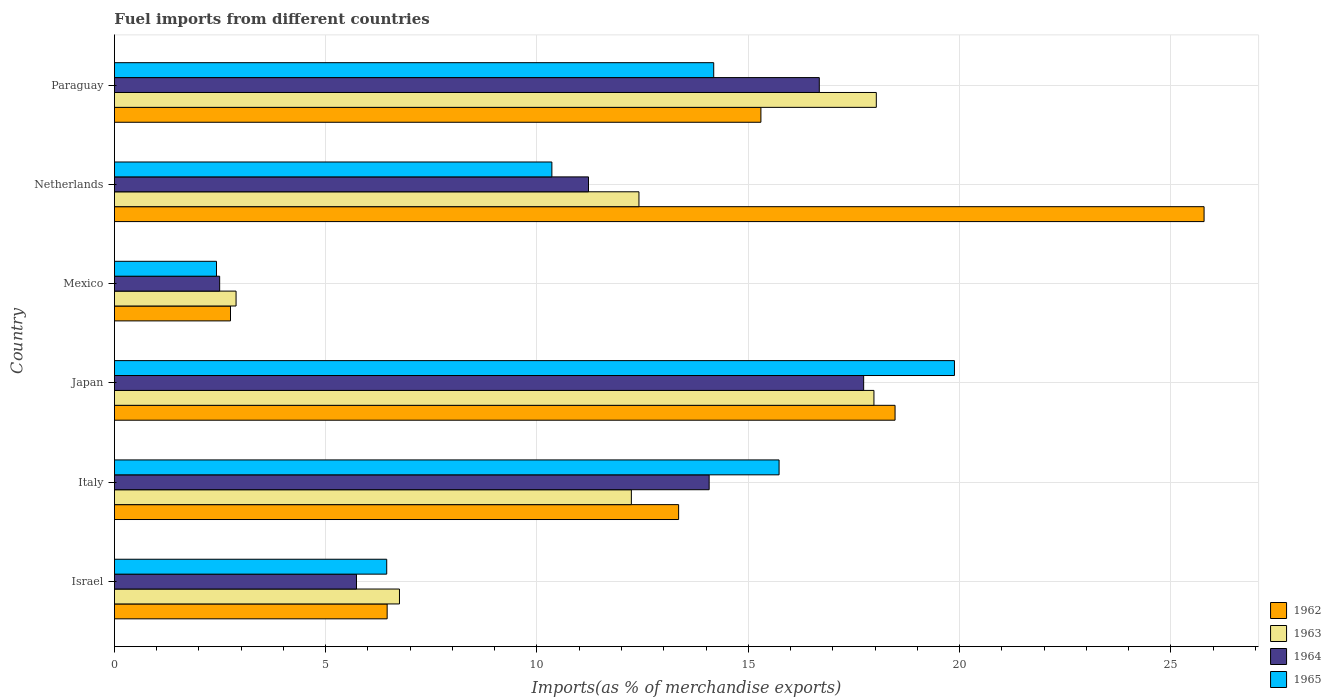Are the number of bars per tick equal to the number of legend labels?
Provide a short and direct response. Yes. How many bars are there on the 3rd tick from the top?
Ensure brevity in your answer.  4. How many bars are there on the 5th tick from the bottom?
Your response must be concise. 4. What is the label of the 5th group of bars from the top?
Keep it short and to the point. Italy. What is the percentage of imports to different countries in 1962 in Japan?
Keep it short and to the point. 18.47. Across all countries, what is the maximum percentage of imports to different countries in 1963?
Ensure brevity in your answer.  18.03. Across all countries, what is the minimum percentage of imports to different countries in 1962?
Provide a short and direct response. 2.75. In which country was the percentage of imports to different countries in 1963 maximum?
Give a very brief answer. Paraguay. What is the total percentage of imports to different countries in 1963 in the graph?
Keep it short and to the point. 70.28. What is the difference between the percentage of imports to different countries in 1963 in Israel and that in Mexico?
Provide a short and direct response. 3.87. What is the difference between the percentage of imports to different countries in 1965 in Italy and the percentage of imports to different countries in 1962 in Paraguay?
Provide a succinct answer. 0.43. What is the average percentage of imports to different countries in 1964 per country?
Your answer should be very brief. 11.32. What is the difference between the percentage of imports to different countries in 1965 and percentage of imports to different countries in 1963 in Mexico?
Your response must be concise. -0.46. In how many countries, is the percentage of imports to different countries in 1963 greater than 24 %?
Make the answer very short. 0. What is the ratio of the percentage of imports to different countries in 1963 in Israel to that in Paraguay?
Your answer should be compact. 0.37. What is the difference between the highest and the second highest percentage of imports to different countries in 1964?
Provide a short and direct response. 1.05. What is the difference between the highest and the lowest percentage of imports to different countries in 1965?
Your answer should be compact. 17.46. Is the sum of the percentage of imports to different countries in 1963 in Japan and Netherlands greater than the maximum percentage of imports to different countries in 1965 across all countries?
Your response must be concise. Yes. Is it the case that in every country, the sum of the percentage of imports to different countries in 1964 and percentage of imports to different countries in 1963 is greater than the sum of percentage of imports to different countries in 1962 and percentage of imports to different countries in 1965?
Keep it short and to the point. No. What does the 4th bar from the top in Italy represents?
Keep it short and to the point. 1962. Is it the case that in every country, the sum of the percentage of imports to different countries in 1963 and percentage of imports to different countries in 1962 is greater than the percentage of imports to different countries in 1964?
Ensure brevity in your answer.  Yes. How many countries are there in the graph?
Keep it short and to the point. 6. What is the difference between two consecutive major ticks on the X-axis?
Ensure brevity in your answer.  5. Are the values on the major ticks of X-axis written in scientific E-notation?
Provide a short and direct response. No. Does the graph contain any zero values?
Give a very brief answer. No. Where does the legend appear in the graph?
Keep it short and to the point. Bottom right. How many legend labels are there?
Your answer should be very brief. 4. What is the title of the graph?
Your answer should be compact. Fuel imports from different countries. Does "1960" appear as one of the legend labels in the graph?
Provide a succinct answer. No. What is the label or title of the X-axis?
Your response must be concise. Imports(as % of merchandise exports). What is the label or title of the Y-axis?
Your answer should be very brief. Country. What is the Imports(as % of merchandise exports) in 1962 in Israel?
Provide a short and direct response. 6.45. What is the Imports(as % of merchandise exports) in 1963 in Israel?
Give a very brief answer. 6.75. What is the Imports(as % of merchandise exports) of 1964 in Israel?
Provide a short and direct response. 5.73. What is the Imports(as % of merchandise exports) in 1965 in Israel?
Keep it short and to the point. 6.44. What is the Imports(as % of merchandise exports) in 1962 in Italy?
Ensure brevity in your answer.  13.35. What is the Imports(as % of merchandise exports) in 1963 in Italy?
Offer a very short reply. 12.23. What is the Imports(as % of merchandise exports) in 1964 in Italy?
Make the answer very short. 14.07. What is the Imports(as % of merchandise exports) of 1965 in Italy?
Keep it short and to the point. 15.73. What is the Imports(as % of merchandise exports) of 1962 in Japan?
Give a very brief answer. 18.47. What is the Imports(as % of merchandise exports) of 1963 in Japan?
Ensure brevity in your answer.  17.97. What is the Imports(as % of merchandise exports) of 1964 in Japan?
Your response must be concise. 17.73. What is the Imports(as % of merchandise exports) of 1965 in Japan?
Give a very brief answer. 19.88. What is the Imports(as % of merchandise exports) of 1962 in Mexico?
Offer a very short reply. 2.75. What is the Imports(as % of merchandise exports) in 1963 in Mexico?
Make the answer very short. 2.88. What is the Imports(as % of merchandise exports) in 1964 in Mexico?
Your response must be concise. 2.49. What is the Imports(as % of merchandise exports) in 1965 in Mexico?
Provide a succinct answer. 2.42. What is the Imports(as % of merchandise exports) in 1962 in Netherlands?
Offer a terse response. 25.79. What is the Imports(as % of merchandise exports) of 1963 in Netherlands?
Ensure brevity in your answer.  12.41. What is the Imports(as % of merchandise exports) in 1964 in Netherlands?
Provide a short and direct response. 11.22. What is the Imports(as % of merchandise exports) of 1965 in Netherlands?
Give a very brief answer. 10.35. What is the Imports(as % of merchandise exports) in 1962 in Paraguay?
Ensure brevity in your answer.  15.3. What is the Imports(as % of merchandise exports) of 1963 in Paraguay?
Your response must be concise. 18.03. What is the Imports(as % of merchandise exports) of 1964 in Paraguay?
Your answer should be very brief. 16.68. What is the Imports(as % of merchandise exports) of 1965 in Paraguay?
Keep it short and to the point. 14.18. Across all countries, what is the maximum Imports(as % of merchandise exports) in 1962?
Make the answer very short. 25.79. Across all countries, what is the maximum Imports(as % of merchandise exports) of 1963?
Your answer should be very brief. 18.03. Across all countries, what is the maximum Imports(as % of merchandise exports) of 1964?
Give a very brief answer. 17.73. Across all countries, what is the maximum Imports(as % of merchandise exports) in 1965?
Make the answer very short. 19.88. Across all countries, what is the minimum Imports(as % of merchandise exports) in 1962?
Ensure brevity in your answer.  2.75. Across all countries, what is the minimum Imports(as % of merchandise exports) of 1963?
Ensure brevity in your answer.  2.88. Across all countries, what is the minimum Imports(as % of merchandise exports) of 1964?
Keep it short and to the point. 2.49. Across all countries, what is the minimum Imports(as % of merchandise exports) of 1965?
Give a very brief answer. 2.42. What is the total Imports(as % of merchandise exports) in 1962 in the graph?
Your answer should be very brief. 82.11. What is the total Imports(as % of merchandise exports) in 1963 in the graph?
Ensure brevity in your answer.  70.28. What is the total Imports(as % of merchandise exports) in 1964 in the graph?
Offer a terse response. 67.93. What is the total Imports(as % of merchandise exports) of 1965 in the graph?
Offer a terse response. 69. What is the difference between the Imports(as % of merchandise exports) of 1962 in Israel and that in Italy?
Make the answer very short. -6.9. What is the difference between the Imports(as % of merchandise exports) in 1963 in Israel and that in Italy?
Provide a succinct answer. -5.49. What is the difference between the Imports(as % of merchandise exports) of 1964 in Israel and that in Italy?
Give a very brief answer. -8.35. What is the difference between the Imports(as % of merchandise exports) in 1965 in Israel and that in Italy?
Make the answer very short. -9.29. What is the difference between the Imports(as % of merchandise exports) in 1962 in Israel and that in Japan?
Your response must be concise. -12.02. What is the difference between the Imports(as % of merchandise exports) in 1963 in Israel and that in Japan?
Make the answer very short. -11.23. What is the difference between the Imports(as % of merchandise exports) of 1964 in Israel and that in Japan?
Provide a succinct answer. -12. What is the difference between the Imports(as % of merchandise exports) of 1965 in Israel and that in Japan?
Offer a terse response. -13.44. What is the difference between the Imports(as % of merchandise exports) in 1962 in Israel and that in Mexico?
Provide a succinct answer. 3.71. What is the difference between the Imports(as % of merchandise exports) of 1963 in Israel and that in Mexico?
Your answer should be very brief. 3.87. What is the difference between the Imports(as % of merchandise exports) in 1964 in Israel and that in Mexico?
Your answer should be compact. 3.24. What is the difference between the Imports(as % of merchandise exports) in 1965 in Israel and that in Mexico?
Provide a short and direct response. 4.03. What is the difference between the Imports(as % of merchandise exports) of 1962 in Israel and that in Netherlands?
Your answer should be very brief. -19.33. What is the difference between the Imports(as % of merchandise exports) of 1963 in Israel and that in Netherlands?
Give a very brief answer. -5.67. What is the difference between the Imports(as % of merchandise exports) in 1964 in Israel and that in Netherlands?
Offer a terse response. -5.49. What is the difference between the Imports(as % of merchandise exports) in 1965 in Israel and that in Netherlands?
Provide a succinct answer. -3.91. What is the difference between the Imports(as % of merchandise exports) of 1962 in Israel and that in Paraguay?
Ensure brevity in your answer.  -8.85. What is the difference between the Imports(as % of merchandise exports) in 1963 in Israel and that in Paraguay?
Make the answer very short. -11.28. What is the difference between the Imports(as % of merchandise exports) in 1964 in Israel and that in Paraguay?
Your answer should be compact. -10.95. What is the difference between the Imports(as % of merchandise exports) of 1965 in Israel and that in Paraguay?
Your answer should be compact. -7.74. What is the difference between the Imports(as % of merchandise exports) of 1962 in Italy and that in Japan?
Your response must be concise. -5.12. What is the difference between the Imports(as % of merchandise exports) in 1963 in Italy and that in Japan?
Offer a terse response. -5.74. What is the difference between the Imports(as % of merchandise exports) of 1964 in Italy and that in Japan?
Offer a very short reply. -3.66. What is the difference between the Imports(as % of merchandise exports) in 1965 in Italy and that in Japan?
Offer a very short reply. -4.15. What is the difference between the Imports(as % of merchandise exports) of 1962 in Italy and that in Mexico?
Offer a very short reply. 10.61. What is the difference between the Imports(as % of merchandise exports) in 1963 in Italy and that in Mexico?
Provide a succinct answer. 9.36. What is the difference between the Imports(as % of merchandise exports) in 1964 in Italy and that in Mexico?
Your answer should be very brief. 11.58. What is the difference between the Imports(as % of merchandise exports) in 1965 in Italy and that in Mexico?
Provide a short and direct response. 13.31. What is the difference between the Imports(as % of merchandise exports) in 1962 in Italy and that in Netherlands?
Offer a terse response. -12.44. What is the difference between the Imports(as % of merchandise exports) of 1963 in Italy and that in Netherlands?
Your answer should be compact. -0.18. What is the difference between the Imports(as % of merchandise exports) in 1964 in Italy and that in Netherlands?
Provide a short and direct response. 2.86. What is the difference between the Imports(as % of merchandise exports) of 1965 in Italy and that in Netherlands?
Give a very brief answer. 5.38. What is the difference between the Imports(as % of merchandise exports) of 1962 in Italy and that in Paraguay?
Your response must be concise. -1.95. What is the difference between the Imports(as % of merchandise exports) of 1963 in Italy and that in Paraguay?
Provide a short and direct response. -5.8. What is the difference between the Imports(as % of merchandise exports) of 1964 in Italy and that in Paraguay?
Provide a succinct answer. -2.61. What is the difference between the Imports(as % of merchandise exports) in 1965 in Italy and that in Paraguay?
Your answer should be compact. 1.55. What is the difference between the Imports(as % of merchandise exports) of 1962 in Japan and that in Mexico?
Offer a terse response. 15.73. What is the difference between the Imports(as % of merchandise exports) in 1963 in Japan and that in Mexico?
Provide a short and direct response. 15.1. What is the difference between the Imports(as % of merchandise exports) in 1964 in Japan and that in Mexico?
Offer a terse response. 15.24. What is the difference between the Imports(as % of merchandise exports) of 1965 in Japan and that in Mexico?
Give a very brief answer. 17.46. What is the difference between the Imports(as % of merchandise exports) of 1962 in Japan and that in Netherlands?
Give a very brief answer. -7.31. What is the difference between the Imports(as % of merchandise exports) in 1963 in Japan and that in Netherlands?
Your response must be concise. 5.56. What is the difference between the Imports(as % of merchandise exports) of 1964 in Japan and that in Netherlands?
Offer a very short reply. 6.51. What is the difference between the Imports(as % of merchandise exports) of 1965 in Japan and that in Netherlands?
Offer a terse response. 9.53. What is the difference between the Imports(as % of merchandise exports) of 1962 in Japan and that in Paraguay?
Offer a terse response. 3.17. What is the difference between the Imports(as % of merchandise exports) of 1963 in Japan and that in Paraguay?
Offer a very short reply. -0.06. What is the difference between the Imports(as % of merchandise exports) in 1964 in Japan and that in Paraguay?
Your response must be concise. 1.05. What is the difference between the Imports(as % of merchandise exports) in 1965 in Japan and that in Paraguay?
Offer a terse response. 5.7. What is the difference between the Imports(as % of merchandise exports) of 1962 in Mexico and that in Netherlands?
Your answer should be compact. -23.04. What is the difference between the Imports(as % of merchandise exports) of 1963 in Mexico and that in Netherlands?
Keep it short and to the point. -9.53. What is the difference between the Imports(as % of merchandise exports) of 1964 in Mexico and that in Netherlands?
Give a very brief answer. -8.73. What is the difference between the Imports(as % of merchandise exports) in 1965 in Mexico and that in Netherlands?
Your response must be concise. -7.94. What is the difference between the Imports(as % of merchandise exports) in 1962 in Mexico and that in Paraguay?
Make the answer very short. -12.55. What is the difference between the Imports(as % of merchandise exports) in 1963 in Mexico and that in Paraguay?
Keep it short and to the point. -15.15. What is the difference between the Imports(as % of merchandise exports) in 1964 in Mexico and that in Paraguay?
Offer a very short reply. -14.19. What is the difference between the Imports(as % of merchandise exports) of 1965 in Mexico and that in Paraguay?
Your response must be concise. -11.77. What is the difference between the Imports(as % of merchandise exports) of 1962 in Netherlands and that in Paraguay?
Your response must be concise. 10.49. What is the difference between the Imports(as % of merchandise exports) in 1963 in Netherlands and that in Paraguay?
Provide a short and direct response. -5.62. What is the difference between the Imports(as % of merchandise exports) of 1964 in Netherlands and that in Paraguay?
Provide a succinct answer. -5.46. What is the difference between the Imports(as % of merchandise exports) in 1965 in Netherlands and that in Paraguay?
Offer a very short reply. -3.83. What is the difference between the Imports(as % of merchandise exports) of 1962 in Israel and the Imports(as % of merchandise exports) of 1963 in Italy?
Ensure brevity in your answer.  -5.78. What is the difference between the Imports(as % of merchandise exports) in 1962 in Israel and the Imports(as % of merchandise exports) in 1964 in Italy?
Your answer should be compact. -7.62. What is the difference between the Imports(as % of merchandise exports) of 1962 in Israel and the Imports(as % of merchandise exports) of 1965 in Italy?
Keep it short and to the point. -9.28. What is the difference between the Imports(as % of merchandise exports) in 1963 in Israel and the Imports(as % of merchandise exports) in 1964 in Italy?
Make the answer very short. -7.33. What is the difference between the Imports(as % of merchandise exports) of 1963 in Israel and the Imports(as % of merchandise exports) of 1965 in Italy?
Your answer should be compact. -8.98. What is the difference between the Imports(as % of merchandise exports) of 1964 in Israel and the Imports(as % of merchandise exports) of 1965 in Italy?
Your answer should be very brief. -10. What is the difference between the Imports(as % of merchandise exports) of 1962 in Israel and the Imports(as % of merchandise exports) of 1963 in Japan?
Give a very brief answer. -11.52. What is the difference between the Imports(as % of merchandise exports) in 1962 in Israel and the Imports(as % of merchandise exports) in 1964 in Japan?
Give a very brief answer. -11.28. What is the difference between the Imports(as % of merchandise exports) in 1962 in Israel and the Imports(as % of merchandise exports) in 1965 in Japan?
Your answer should be compact. -13.43. What is the difference between the Imports(as % of merchandise exports) in 1963 in Israel and the Imports(as % of merchandise exports) in 1964 in Japan?
Your answer should be compact. -10.99. What is the difference between the Imports(as % of merchandise exports) in 1963 in Israel and the Imports(as % of merchandise exports) in 1965 in Japan?
Keep it short and to the point. -13.13. What is the difference between the Imports(as % of merchandise exports) of 1964 in Israel and the Imports(as % of merchandise exports) of 1965 in Japan?
Provide a short and direct response. -14.15. What is the difference between the Imports(as % of merchandise exports) of 1962 in Israel and the Imports(as % of merchandise exports) of 1963 in Mexico?
Your response must be concise. 3.58. What is the difference between the Imports(as % of merchandise exports) in 1962 in Israel and the Imports(as % of merchandise exports) in 1964 in Mexico?
Your response must be concise. 3.96. What is the difference between the Imports(as % of merchandise exports) of 1962 in Israel and the Imports(as % of merchandise exports) of 1965 in Mexico?
Offer a very short reply. 4.04. What is the difference between the Imports(as % of merchandise exports) of 1963 in Israel and the Imports(as % of merchandise exports) of 1964 in Mexico?
Make the answer very short. 4.26. What is the difference between the Imports(as % of merchandise exports) in 1963 in Israel and the Imports(as % of merchandise exports) in 1965 in Mexico?
Provide a succinct answer. 4.33. What is the difference between the Imports(as % of merchandise exports) of 1964 in Israel and the Imports(as % of merchandise exports) of 1965 in Mexico?
Offer a terse response. 3.31. What is the difference between the Imports(as % of merchandise exports) of 1962 in Israel and the Imports(as % of merchandise exports) of 1963 in Netherlands?
Ensure brevity in your answer.  -5.96. What is the difference between the Imports(as % of merchandise exports) in 1962 in Israel and the Imports(as % of merchandise exports) in 1964 in Netherlands?
Your response must be concise. -4.76. What is the difference between the Imports(as % of merchandise exports) in 1962 in Israel and the Imports(as % of merchandise exports) in 1965 in Netherlands?
Your answer should be very brief. -3.9. What is the difference between the Imports(as % of merchandise exports) of 1963 in Israel and the Imports(as % of merchandise exports) of 1964 in Netherlands?
Offer a very short reply. -4.47. What is the difference between the Imports(as % of merchandise exports) in 1963 in Israel and the Imports(as % of merchandise exports) in 1965 in Netherlands?
Keep it short and to the point. -3.61. What is the difference between the Imports(as % of merchandise exports) in 1964 in Israel and the Imports(as % of merchandise exports) in 1965 in Netherlands?
Your answer should be compact. -4.62. What is the difference between the Imports(as % of merchandise exports) in 1962 in Israel and the Imports(as % of merchandise exports) in 1963 in Paraguay?
Your answer should be compact. -11.58. What is the difference between the Imports(as % of merchandise exports) of 1962 in Israel and the Imports(as % of merchandise exports) of 1964 in Paraguay?
Keep it short and to the point. -10.23. What is the difference between the Imports(as % of merchandise exports) in 1962 in Israel and the Imports(as % of merchandise exports) in 1965 in Paraguay?
Offer a terse response. -7.73. What is the difference between the Imports(as % of merchandise exports) in 1963 in Israel and the Imports(as % of merchandise exports) in 1964 in Paraguay?
Your answer should be very brief. -9.94. What is the difference between the Imports(as % of merchandise exports) of 1963 in Israel and the Imports(as % of merchandise exports) of 1965 in Paraguay?
Offer a terse response. -7.44. What is the difference between the Imports(as % of merchandise exports) in 1964 in Israel and the Imports(as % of merchandise exports) in 1965 in Paraguay?
Provide a succinct answer. -8.45. What is the difference between the Imports(as % of merchandise exports) in 1962 in Italy and the Imports(as % of merchandise exports) in 1963 in Japan?
Your answer should be compact. -4.62. What is the difference between the Imports(as % of merchandise exports) of 1962 in Italy and the Imports(as % of merchandise exports) of 1964 in Japan?
Keep it short and to the point. -4.38. What is the difference between the Imports(as % of merchandise exports) in 1962 in Italy and the Imports(as % of merchandise exports) in 1965 in Japan?
Provide a short and direct response. -6.53. What is the difference between the Imports(as % of merchandise exports) in 1963 in Italy and the Imports(as % of merchandise exports) in 1964 in Japan?
Your response must be concise. -5.5. What is the difference between the Imports(as % of merchandise exports) of 1963 in Italy and the Imports(as % of merchandise exports) of 1965 in Japan?
Give a very brief answer. -7.65. What is the difference between the Imports(as % of merchandise exports) in 1964 in Italy and the Imports(as % of merchandise exports) in 1965 in Japan?
Provide a short and direct response. -5.8. What is the difference between the Imports(as % of merchandise exports) of 1962 in Italy and the Imports(as % of merchandise exports) of 1963 in Mexico?
Offer a very short reply. 10.47. What is the difference between the Imports(as % of merchandise exports) in 1962 in Italy and the Imports(as % of merchandise exports) in 1964 in Mexico?
Your answer should be very brief. 10.86. What is the difference between the Imports(as % of merchandise exports) of 1962 in Italy and the Imports(as % of merchandise exports) of 1965 in Mexico?
Provide a succinct answer. 10.94. What is the difference between the Imports(as % of merchandise exports) of 1963 in Italy and the Imports(as % of merchandise exports) of 1964 in Mexico?
Provide a succinct answer. 9.74. What is the difference between the Imports(as % of merchandise exports) of 1963 in Italy and the Imports(as % of merchandise exports) of 1965 in Mexico?
Ensure brevity in your answer.  9.82. What is the difference between the Imports(as % of merchandise exports) in 1964 in Italy and the Imports(as % of merchandise exports) in 1965 in Mexico?
Make the answer very short. 11.66. What is the difference between the Imports(as % of merchandise exports) in 1962 in Italy and the Imports(as % of merchandise exports) in 1963 in Netherlands?
Provide a succinct answer. 0.94. What is the difference between the Imports(as % of merchandise exports) in 1962 in Italy and the Imports(as % of merchandise exports) in 1964 in Netherlands?
Offer a terse response. 2.13. What is the difference between the Imports(as % of merchandise exports) in 1962 in Italy and the Imports(as % of merchandise exports) in 1965 in Netherlands?
Provide a succinct answer. 3. What is the difference between the Imports(as % of merchandise exports) in 1963 in Italy and the Imports(as % of merchandise exports) in 1964 in Netherlands?
Make the answer very short. 1.01. What is the difference between the Imports(as % of merchandise exports) in 1963 in Italy and the Imports(as % of merchandise exports) in 1965 in Netherlands?
Ensure brevity in your answer.  1.88. What is the difference between the Imports(as % of merchandise exports) in 1964 in Italy and the Imports(as % of merchandise exports) in 1965 in Netherlands?
Your answer should be very brief. 3.72. What is the difference between the Imports(as % of merchandise exports) of 1962 in Italy and the Imports(as % of merchandise exports) of 1963 in Paraguay?
Offer a very short reply. -4.68. What is the difference between the Imports(as % of merchandise exports) in 1962 in Italy and the Imports(as % of merchandise exports) in 1964 in Paraguay?
Give a very brief answer. -3.33. What is the difference between the Imports(as % of merchandise exports) of 1962 in Italy and the Imports(as % of merchandise exports) of 1965 in Paraguay?
Offer a terse response. -0.83. What is the difference between the Imports(as % of merchandise exports) in 1963 in Italy and the Imports(as % of merchandise exports) in 1964 in Paraguay?
Offer a very short reply. -4.45. What is the difference between the Imports(as % of merchandise exports) in 1963 in Italy and the Imports(as % of merchandise exports) in 1965 in Paraguay?
Your response must be concise. -1.95. What is the difference between the Imports(as % of merchandise exports) of 1964 in Italy and the Imports(as % of merchandise exports) of 1965 in Paraguay?
Offer a very short reply. -0.11. What is the difference between the Imports(as % of merchandise exports) in 1962 in Japan and the Imports(as % of merchandise exports) in 1963 in Mexico?
Ensure brevity in your answer.  15.6. What is the difference between the Imports(as % of merchandise exports) in 1962 in Japan and the Imports(as % of merchandise exports) in 1964 in Mexico?
Make the answer very short. 15.98. What is the difference between the Imports(as % of merchandise exports) of 1962 in Japan and the Imports(as % of merchandise exports) of 1965 in Mexico?
Your response must be concise. 16.06. What is the difference between the Imports(as % of merchandise exports) in 1963 in Japan and the Imports(as % of merchandise exports) in 1964 in Mexico?
Offer a very short reply. 15.48. What is the difference between the Imports(as % of merchandise exports) of 1963 in Japan and the Imports(as % of merchandise exports) of 1965 in Mexico?
Your response must be concise. 15.56. What is the difference between the Imports(as % of merchandise exports) in 1964 in Japan and the Imports(as % of merchandise exports) in 1965 in Mexico?
Give a very brief answer. 15.32. What is the difference between the Imports(as % of merchandise exports) in 1962 in Japan and the Imports(as % of merchandise exports) in 1963 in Netherlands?
Give a very brief answer. 6.06. What is the difference between the Imports(as % of merchandise exports) of 1962 in Japan and the Imports(as % of merchandise exports) of 1964 in Netherlands?
Make the answer very short. 7.25. What is the difference between the Imports(as % of merchandise exports) of 1962 in Japan and the Imports(as % of merchandise exports) of 1965 in Netherlands?
Make the answer very short. 8.12. What is the difference between the Imports(as % of merchandise exports) in 1963 in Japan and the Imports(as % of merchandise exports) in 1964 in Netherlands?
Offer a terse response. 6.76. What is the difference between the Imports(as % of merchandise exports) of 1963 in Japan and the Imports(as % of merchandise exports) of 1965 in Netherlands?
Make the answer very short. 7.62. What is the difference between the Imports(as % of merchandise exports) of 1964 in Japan and the Imports(as % of merchandise exports) of 1965 in Netherlands?
Give a very brief answer. 7.38. What is the difference between the Imports(as % of merchandise exports) of 1962 in Japan and the Imports(as % of merchandise exports) of 1963 in Paraguay?
Keep it short and to the point. 0.44. What is the difference between the Imports(as % of merchandise exports) in 1962 in Japan and the Imports(as % of merchandise exports) in 1964 in Paraguay?
Your answer should be compact. 1.79. What is the difference between the Imports(as % of merchandise exports) in 1962 in Japan and the Imports(as % of merchandise exports) in 1965 in Paraguay?
Provide a succinct answer. 4.29. What is the difference between the Imports(as % of merchandise exports) in 1963 in Japan and the Imports(as % of merchandise exports) in 1964 in Paraguay?
Ensure brevity in your answer.  1.29. What is the difference between the Imports(as % of merchandise exports) in 1963 in Japan and the Imports(as % of merchandise exports) in 1965 in Paraguay?
Offer a terse response. 3.79. What is the difference between the Imports(as % of merchandise exports) of 1964 in Japan and the Imports(as % of merchandise exports) of 1965 in Paraguay?
Ensure brevity in your answer.  3.55. What is the difference between the Imports(as % of merchandise exports) of 1962 in Mexico and the Imports(as % of merchandise exports) of 1963 in Netherlands?
Your answer should be very brief. -9.67. What is the difference between the Imports(as % of merchandise exports) of 1962 in Mexico and the Imports(as % of merchandise exports) of 1964 in Netherlands?
Your answer should be compact. -8.47. What is the difference between the Imports(as % of merchandise exports) in 1962 in Mexico and the Imports(as % of merchandise exports) in 1965 in Netherlands?
Provide a short and direct response. -7.61. What is the difference between the Imports(as % of merchandise exports) in 1963 in Mexico and the Imports(as % of merchandise exports) in 1964 in Netherlands?
Give a very brief answer. -8.34. What is the difference between the Imports(as % of merchandise exports) in 1963 in Mexico and the Imports(as % of merchandise exports) in 1965 in Netherlands?
Provide a short and direct response. -7.47. What is the difference between the Imports(as % of merchandise exports) in 1964 in Mexico and the Imports(as % of merchandise exports) in 1965 in Netherlands?
Provide a succinct answer. -7.86. What is the difference between the Imports(as % of merchandise exports) of 1962 in Mexico and the Imports(as % of merchandise exports) of 1963 in Paraguay?
Keep it short and to the point. -15.28. What is the difference between the Imports(as % of merchandise exports) of 1962 in Mexico and the Imports(as % of merchandise exports) of 1964 in Paraguay?
Your answer should be very brief. -13.93. What is the difference between the Imports(as % of merchandise exports) in 1962 in Mexico and the Imports(as % of merchandise exports) in 1965 in Paraguay?
Offer a terse response. -11.44. What is the difference between the Imports(as % of merchandise exports) of 1963 in Mexico and the Imports(as % of merchandise exports) of 1964 in Paraguay?
Your answer should be very brief. -13.8. What is the difference between the Imports(as % of merchandise exports) in 1963 in Mexico and the Imports(as % of merchandise exports) in 1965 in Paraguay?
Give a very brief answer. -11.3. What is the difference between the Imports(as % of merchandise exports) in 1964 in Mexico and the Imports(as % of merchandise exports) in 1965 in Paraguay?
Make the answer very short. -11.69. What is the difference between the Imports(as % of merchandise exports) in 1962 in Netherlands and the Imports(as % of merchandise exports) in 1963 in Paraguay?
Your answer should be compact. 7.76. What is the difference between the Imports(as % of merchandise exports) of 1962 in Netherlands and the Imports(as % of merchandise exports) of 1964 in Paraguay?
Give a very brief answer. 9.11. What is the difference between the Imports(as % of merchandise exports) in 1962 in Netherlands and the Imports(as % of merchandise exports) in 1965 in Paraguay?
Give a very brief answer. 11.6. What is the difference between the Imports(as % of merchandise exports) in 1963 in Netherlands and the Imports(as % of merchandise exports) in 1964 in Paraguay?
Keep it short and to the point. -4.27. What is the difference between the Imports(as % of merchandise exports) in 1963 in Netherlands and the Imports(as % of merchandise exports) in 1965 in Paraguay?
Ensure brevity in your answer.  -1.77. What is the difference between the Imports(as % of merchandise exports) of 1964 in Netherlands and the Imports(as % of merchandise exports) of 1965 in Paraguay?
Provide a succinct answer. -2.96. What is the average Imports(as % of merchandise exports) in 1962 per country?
Provide a short and direct response. 13.69. What is the average Imports(as % of merchandise exports) in 1963 per country?
Your answer should be very brief. 11.71. What is the average Imports(as % of merchandise exports) of 1964 per country?
Give a very brief answer. 11.32. What is the average Imports(as % of merchandise exports) of 1965 per country?
Your answer should be very brief. 11.5. What is the difference between the Imports(as % of merchandise exports) in 1962 and Imports(as % of merchandise exports) in 1963 in Israel?
Provide a short and direct response. -0.29. What is the difference between the Imports(as % of merchandise exports) in 1962 and Imports(as % of merchandise exports) in 1964 in Israel?
Ensure brevity in your answer.  0.73. What is the difference between the Imports(as % of merchandise exports) of 1962 and Imports(as % of merchandise exports) of 1965 in Israel?
Offer a terse response. 0.01. What is the difference between the Imports(as % of merchandise exports) of 1963 and Imports(as % of merchandise exports) of 1964 in Israel?
Ensure brevity in your answer.  1.02. What is the difference between the Imports(as % of merchandise exports) in 1963 and Imports(as % of merchandise exports) in 1965 in Israel?
Your response must be concise. 0.3. What is the difference between the Imports(as % of merchandise exports) of 1964 and Imports(as % of merchandise exports) of 1965 in Israel?
Your response must be concise. -0.72. What is the difference between the Imports(as % of merchandise exports) in 1962 and Imports(as % of merchandise exports) in 1963 in Italy?
Provide a short and direct response. 1.12. What is the difference between the Imports(as % of merchandise exports) of 1962 and Imports(as % of merchandise exports) of 1964 in Italy?
Ensure brevity in your answer.  -0.72. What is the difference between the Imports(as % of merchandise exports) in 1962 and Imports(as % of merchandise exports) in 1965 in Italy?
Make the answer very short. -2.38. What is the difference between the Imports(as % of merchandise exports) of 1963 and Imports(as % of merchandise exports) of 1964 in Italy?
Give a very brief answer. -1.84. What is the difference between the Imports(as % of merchandise exports) of 1963 and Imports(as % of merchandise exports) of 1965 in Italy?
Ensure brevity in your answer.  -3.5. What is the difference between the Imports(as % of merchandise exports) of 1964 and Imports(as % of merchandise exports) of 1965 in Italy?
Keep it short and to the point. -1.65. What is the difference between the Imports(as % of merchandise exports) of 1962 and Imports(as % of merchandise exports) of 1964 in Japan?
Your answer should be compact. 0.74. What is the difference between the Imports(as % of merchandise exports) of 1962 and Imports(as % of merchandise exports) of 1965 in Japan?
Make the answer very short. -1.41. What is the difference between the Imports(as % of merchandise exports) in 1963 and Imports(as % of merchandise exports) in 1964 in Japan?
Provide a short and direct response. 0.24. What is the difference between the Imports(as % of merchandise exports) in 1963 and Imports(as % of merchandise exports) in 1965 in Japan?
Give a very brief answer. -1.91. What is the difference between the Imports(as % of merchandise exports) in 1964 and Imports(as % of merchandise exports) in 1965 in Japan?
Give a very brief answer. -2.15. What is the difference between the Imports(as % of merchandise exports) in 1962 and Imports(as % of merchandise exports) in 1963 in Mexico?
Keep it short and to the point. -0.13. What is the difference between the Imports(as % of merchandise exports) in 1962 and Imports(as % of merchandise exports) in 1964 in Mexico?
Provide a short and direct response. 0.26. What is the difference between the Imports(as % of merchandise exports) in 1962 and Imports(as % of merchandise exports) in 1965 in Mexico?
Offer a terse response. 0.33. What is the difference between the Imports(as % of merchandise exports) of 1963 and Imports(as % of merchandise exports) of 1964 in Mexico?
Give a very brief answer. 0.39. What is the difference between the Imports(as % of merchandise exports) in 1963 and Imports(as % of merchandise exports) in 1965 in Mexico?
Your answer should be very brief. 0.46. What is the difference between the Imports(as % of merchandise exports) of 1964 and Imports(as % of merchandise exports) of 1965 in Mexico?
Ensure brevity in your answer.  0.07. What is the difference between the Imports(as % of merchandise exports) of 1962 and Imports(as % of merchandise exports) of 1963 in Netherlands?
Ensure brevity in your answer.  13.37. What is the difference between the Imports(as % of merchandise exports) of 1962 and Imports(as % of merchandise exports) of 1964 in Netherlands?
Your answer should be compact. 14.57. What is the difference between the Imports(as % of merchandise exports) in 1962 and Imports(as % of merchandise exports) in 1965 in Netherlands?
Keep it short and to the point. 15.43. What is the difference between the Imports(as % of merchandise exports) in 1963 and Imports(as % of merchandise exports) in 1964 in Netherlands?
Give a very brief answer. 1.19. What is the difference between the Imports(as % of merchandise exports) in 1963 and Imports(as % of merchandise exports) in 1965 in Netherlands?
Offer a terse response. 2.06. What is the difference between the Imports(as % of merchandise exports) of 1964 and Imports(as % of merchandise exports) of 1965 in Netherlands?
Your answer should be very brief. 0.87. What is the difference between the Imports(as % of merchandise exports) of 1962 and Imports(as % of merchandise exports) of 1963 in Paraguay?
Your response must be concise. -2.73. What is the difference between the Imports(as % of merchandise exports) in 1962 and Imports(as % of merchandise exports) in 1964 in Paraguay?
Keep it short and to the point. -1.38. What is the difference between the Imports(as % of merchandise exports) of 1962 and Imports(as % of merchandise exports) of 1965 in Paraguay?
Your response must be concise. 1.12. What is the difference between the Imports(as % of merchandise exports) of 1963 and Imports(as % of merchandise exports) of 1964 in Paraguay?
Ensure brevity in your answer.  1.35. What is the difference between the Imports(as % of merchandise exports) of 1963 and Imports(as % of merchandise exports) of 1965 in Paraguay?
Give a very brief answer. 3.85. What is the difference between the Imports(as % of merchandise exports) of 1964 and Imports(as % of merchandise exports) of 1965 in Paraguay?
Offer a terse response. 2.5. What is the ratio of the Imports(as % of merchandise exports) of 1962 in Israel to that in Italy?
Offer a terse response. 0.48. What is the ratio of the Imports(as % of merchandise exports) in 1963 in Israel to that in Italy?
Provide a succinct answer. 0.55. What is the ratio of the Imports(as % of merchandise exports) of 1964 in Israel to that in Italy?
Make the answer very short. 0.41. What is the ratio of the Imports(as % of merchandise exports) of 1965 in Israel to that in Italy?
Provide a succinct answer. 0.41. What is the ratio of the Imports(as % of merchandise exports) in 1962 in Israel to that in Japan?
Make the answer very short. 0.35. What is the ratio of the Imports(as % of merchandise exports) in 1963 in Israel to that in Japan?
Keep it short and to the point. 0.38. What is the ratio of the Imports(as % of merchandise exports) in 1964 in Israel to that in Japan?
Ensure brevity in your answer.  0.32. What is the ratio of the Imports(as % of merchandise exports) in 1965 in Israel to that in Japan?
Offer a terse response. 0.32. What is the ratio of the Imports(as % of merchandise exports) in 1962 in Israel to that in Mexico?
Provide a succinct answer. 2.35. What is the ratio of the Imports(as % of merchandise exports) in 1963 in Israel to that in Mexico?
Provide a succinct answer. 2.34. What is the ratio of the Imports(as % of merchandise exports) in 1964 in Israel to that in Mexico?
Your answer should be compact. 2.3. What is the ratio of the Imports(as % of merchandise exports) in 1965 in Israel to that in Mexico?
Your answer should be compact. 2.67. What is the ratio of the Imports(as % of merchandise exports) of 1962 in Israel to that in Netherlands?
Provide a short and direct response. 0.25. What is the ratio of the Imports(as % of merchandise exports) in 1963 in Israel to that in Netherlands?
Your response must be concise. 0.54. What is the ratio of the Imports(as % of merchandise exports) in 1964 in Israel to that in Netherlands?
Make the answer very short. 0.51. What is the ratio of the Imports(as % of merchandise exports) in 1965 in Israel to that in Netherlands?
Your response must be concise. 0.62. What is the ratio of the Imports(as % of merchandise exports) in 1962 in Israel to that in Paraguay?
Your answer should be very brief. 0.42. What is the ratio of the Imports(as % of merchandise exports) of 1963 in Israel to that in Paraguay?
Give a very brief answer. 0.37. What is the ratio of the Imports(as % of merchandise exports) in 1964 in Israel to that in Paraguay?
Give a very brief answer. 0.34. What is the ratio of the Imports(as % of merchandise exports) of 1965 in Israel to that in Paraguay?
Give a very brief answer. 0.45. What is the ratio of the Imports(as % of merchandise exports) of 1962 in Italy to that in Japan?
Ensure brevity in your answer.  0.72. What is the ratio of the Imports(as % of merchandise exports) of 1963 in Italy to that in Japan?
Make the answer very short. 0.68. What is the ratio of the Imports(as % of merchandise exports) in 1964 in Italy to that in Japan?
Offer a very short reply. 0.79. What is the ratio of the Imports(as % of merchandise exports) of 1965 in Italy to that in Japan?
Your response must be concise. 0.79. What is the ratio of the Imports(as % of merchandise exports) of 1962 in Italy to that in Mexico?
Ensure brevity in your answer.  4.86. What is the ratio of the Imports(as % of merchandise exports) in 1963 in Italy to that in Mexico?
Ensure brevity in your answer.  4.25. What is the ratio of the Imports(as % of merchandise exports) of 1964 in Italy to that in Mexico?
Provide a short and direct response. 5.65. What is the ratio of the Imports(as % of merchandise exports) in 1965 in Italy to that in Mexico?
Give a very brief answer. 6.51. What is the ratio of the Imports(as % of merchandise exports) of 1962 in Italy to that in Netherlands?
Your answer should be compact. 0.52. What is the ratio of the Imports(as % of merchandise exports) in 1963 in Italy to that in Netherlands?
Offer a very short reply. 0.99. What is the ratio of the Imports(as % of merchandise exports) of 1964 in Italy to that in Netherlands?
Provide a succinct answer. 1.25. What is the ratio of the Imports(as % of merchandise exports) of 1965 in Italy to that in Netherlands?
Your answer should be very brief. 1.52. What is the ratio of the Imports(as % of merchandise exports) of 1962 in Italy to that in Paraguay?
Give a very brief answer. 0.87. What is the ratio of the Imports(as % of merchandise exports) of 1963 in Italy to that in Paraguay?
Give a very brief answer. 0.68. What is the ratio of the Imports(as % of merchandise exports) in 1964 in Italy to that in Paraguay?
Your answer should be compact. 0.84. What is the ratio of the Imports(as % of merchandise exports) of 1965 in Italy to that in Paraguay?
Your response must be concise. 1.11. What is the ratio of the Imports(as % of merchandise exports) in 1962 in Japan to that in Mexico?
Give a very brief answer. 6.72. What is the ratio of the Imports(as % of merchandise exports) of 1963 in Japan to that in Mexico?
Keep it short and to the point. 6.24. What is the ratio of the Imports(as % of merchandise exports) of 1964 in Japan to that in Mexico?
Your answer should be compact. 7.12. What is the ratio of the Imports(as % of merchandise exports) in 1965 in Japan to that in Mexico?
Offer a terse response. 8.23. What is the ratio of the Imports(as % of merchandise exports) in 1962 in Japan to that in Netherlands?
Provide a succinct answer. 0.72. What is the ratio of the Imports(as % of merchandise exports) of 1963 in Japan to that in Netherlands?
Ensure brevity in your answer.  1.45. What is the ratio of the Imports(as % of merchandise exports) of 1964 in Japan to that in Netherlands?
Provide a succinct answer. 1.58. What is the ratio of the Imports(as % of merchandise exports) in 1965 in Japan to that in Netherlands?
Provide a succinct answer. 1.92. What is the ratio of the Imports(as % of merchandise exports) in 1962 in Japan to that in Paraguay?
Provide a succinct answer. 1.21. What is the ratio of the Imports(as % of merchandise exports) of 1964 in Japan to that in Paraguay?
Offer a very short reply. 1.06. What is the ratio of the Imports(as % of merchandise exports) in 1965 in Japan to that in Paraguay?
Your response must be concise. 1.4. What is the ratio of the Imports(as % of merchandise exports) in 1962 in Mexico to that in Netherlands?
Provide a succinct answer. 0.11. What is the ratio of the Imports(as % of merchandise exports) in 1963 in Mexico to that in Netherlands?
Give a very brief answer. 0.23. What is the ratio of the Imports(as % of merchandise exports) of 1964 in Mexico to that in Netherlands?
Provide a succinct answer. 0.22. What is the ratio of the Imports(as % of merchandise exports) of 1965 in Mexico to that in Netherlands?
Your answer should be very brief. 0.23. What is the ratio of the Imports(as % of merchandise exports) in 1962 in Mexico to that in Paraguay?
Provide a short and direct response. 0.18. What is the ratio of the Imports(as % of merchandise exports) of 1963 in Mexico to that in Paraguay?
Offer a terse response. 0.16. What is the ratio of the Imports(as % of merchandise exports) of 1964 in Mexico to that in Paraguay?
Offer a terse response. 0.15. What is the ratio of the Imports(as % of merchandise exports) in 1965 in Mexico to that in Paraguay?
Your answer should be very brief. 0.17. What is the ratio of the Imports(as % of merchandise exports) of 1962 in Netherlands to that in Paraguay?
Your response must be concise. 1.69. What is the ratio of the Imports(as % of merchandise exports) in 1963 in Netherlands to that in Paraguay?
Make the answer very short. 0.69. What is the ratio of the Imports(as % of merchandise exports) of 1964 in Netherlands to that in Paraguay?
Provide a succinct answer. 0.67. What is the ratio of the Imports(as % of merchandise exports) in 1965 in Netherlands to that in Paraguay?
Give a very brief answer. 0.73. What is the difference between the highest and the second highest Imports(as % of merchandise exports) of 1962?
Keep it short and to the point. 7.31. What is the difference between the highest and the second highest Imports(as % of merchandise exports) in 1963?
Give a very brief answer. 0.06. What is the difference between the highest and the second highest Imports(as % of merchandise exports) in 1964?
Offer a terse response. 1.05. What is the difference between the highest and the second highest Imports(as % of merchandise exports) in 1965?
Give a very brief answer. 4.15. What is the difference between the highest and the lowest Imports(as % of merchandise exports) in 1962?
Your response must be concise. 23.04. What is the difference between the highest and the lowest Imports(as % of merchandise exports) of 1963?
Keep it short and to the point. 15.15. What is the difference between the highest and the lowest Imports(as % of merchandise exports) of 1964?
Your answer should be very brief. 15.24. What is the difference between the highest and the lowest Imports(as % of merchandise exports) in 1965?
Offer a terse response. 17.46. 